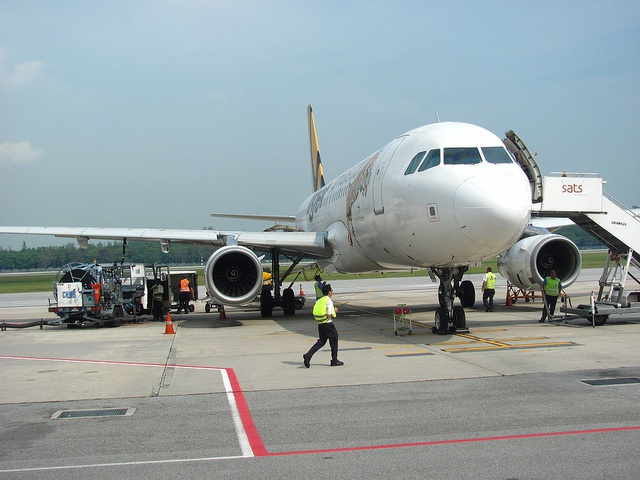Describe the objects in this image and their specific colors. I can see airplane in lightblue, darkgray, white, gray, and black tones, people in lightblue, black, yellow, gray, and white tones, people in lightblue, black, darkgreen, gray, and green tones, people in lightblue, black, khaki, darkgray, and lightgray tones, and people in lightblue, black, gray, and darkgreen tones in this image. 